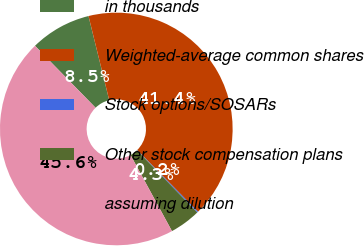Convert chart. <chart><loc_0><loc_0><loc_500><loc_500><pie_chart><fcel>in thousands<fcel>Weighted-average common shares<fcel>Stock options/SOSARs<fcel>Other stock compensation plans<fcel>assuming dilution<nl><fcel>8.48%<fcel>41.44%<fcel>0.15%<fcel>4.31%<fcel>45.61%<nl></chart> 